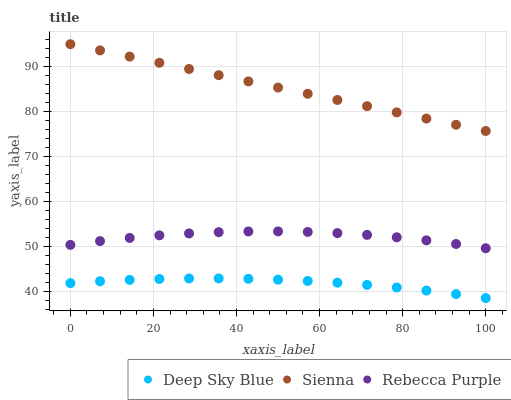Does Deep Sky Blue have the minimum area under the curve?
Answer yes or no. Yes. Does Sienna have the maximum area under the curve?
Answer yes or no. Yes. Does Rebecca Purple have the minimum area under the curve?
Answer yes or no. No. Does Rebecca Purple have the maximum area under the curve?
Answer yes or no. No. Is Sienna the smoothest?
Answer yes or no. Yes. Is Rebecca Purple the roughest?
Answer yes or no. Yes. Is Deep Sky Blue the smoothest?
Answer yes or no. No. Is Deep Sky Blue the roughest?
Answer yes or no. No. Does Deep Sky Blue have the lowest value?
Answer yes or no. Yes. Does Rebecca Purple have the lowest value?
Answer yes or no. No. Does Sienna have the highest value?
Answer yes or no. Yes. Does Rebecca Purple have the highest value?
Answer yes or no. No. Is Deep Sky Blue less than Rebecca Purple?
Answer yes or no. Yes. Is Sienna greater than Deep Sky Blue?
Answer yes or no. Yes. Does Deep Sky Blue intersect Rebecca Purple?
Answer yes or no. No. 